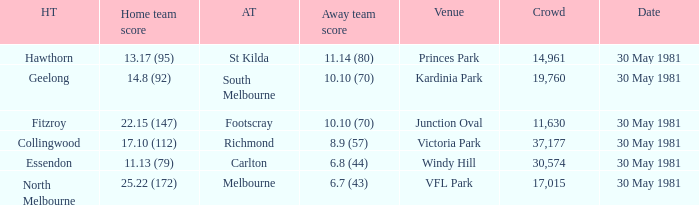What team played away at vfl park? Melbourne. 